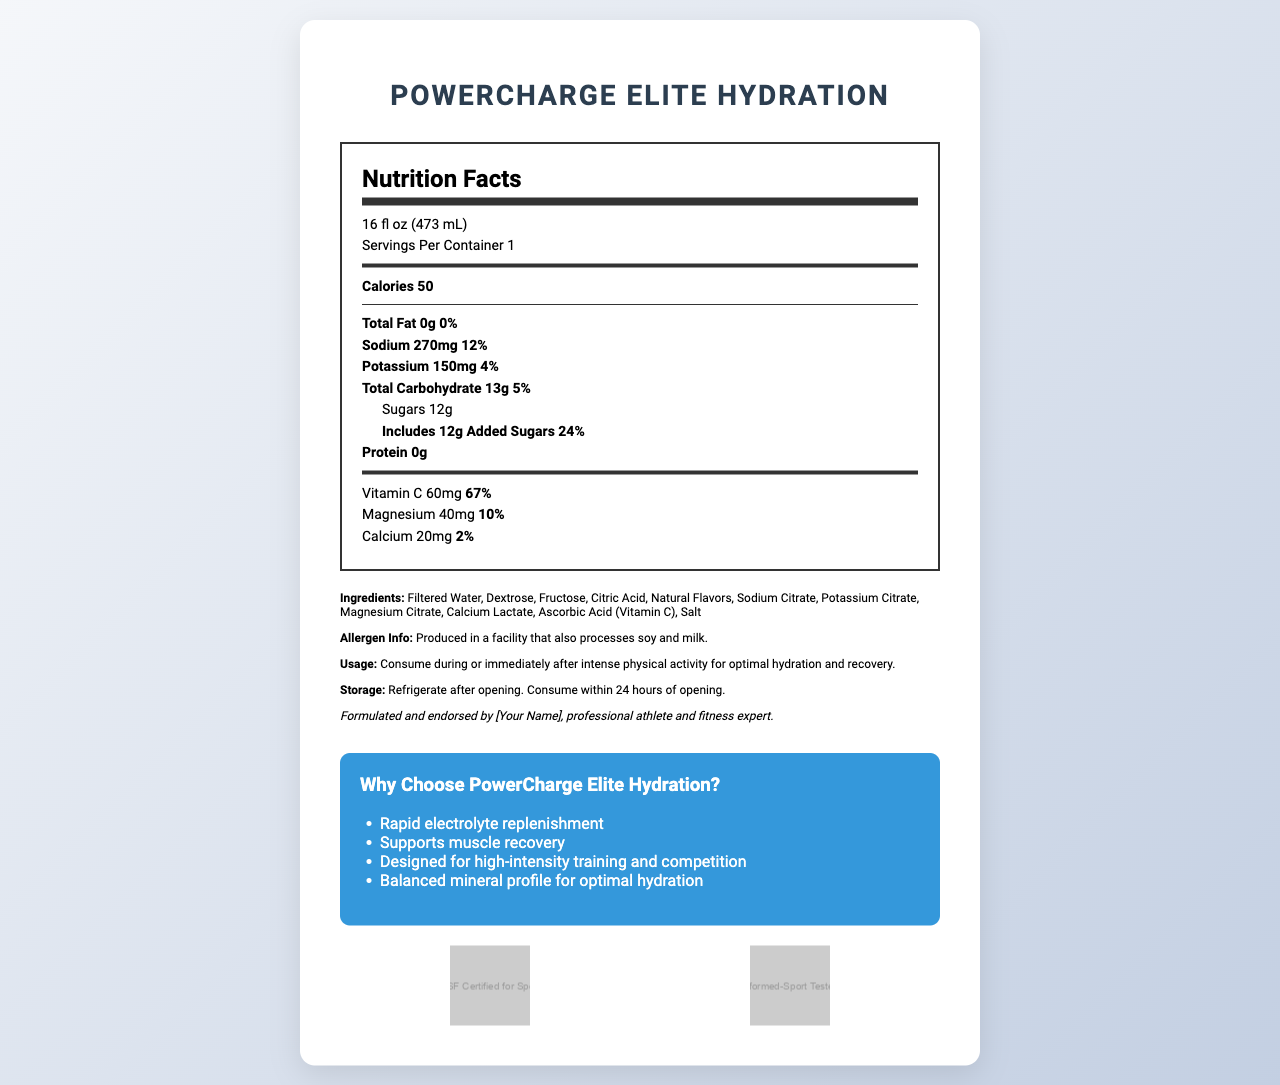where is the product's serving size listed? The serving size is located at the top of the nutrition label and is specified as 16 fl oz (473 mL).
Answer: 16 fl oz (473 mL) how many calories are in one serving? The number of calories per serving is listed at the top of the Nutrition Facts section and is 50 calories.
Answer: 50 what percentage of the daily value for sodium does one serving provide? The daily value percentage for sodium is listed next to the sodium amount and is specified as 12%.
Answer: 12% what is the amount of potassium in one serving? The amount of potassium is listed under sodium in the Nutrition Facts section with an amount of 150mg.
Answer: 150mg what percentage of the daily value for magnesium does one serving provide? The daily value percentage for magnesium is listed near the bottom of the Nutrition Facts and is specified as 10%.
Answer: 10% what are the first three ingredients listed? The first three ingredients listed in the Ingredients section are Filtered Water, Dextrose, and Fructose.
Answer: Filtered Water, Dextrose, Fructose what is the total carbohydrate content per serving? The total carbohydrate content per serving is listed under the Nutrition Facts and is specified as 13g.
Answer: 13g how much added sugar is in one serving? The amount of added sugar is listed under Total Carbohydrate in the Nutrition Facts section and is specified as 12g.
Answer: 12g what vitamins or minerals contribute to immunity support in this drink? A. Magnesium and Calcium B. Vitamin C and Magnesium C. Vitamin C and Potassium D. Sodium and Potassium Vitamin C and Potassium are listed in the Nutrition Facts section, and Vitamin C is known for its contributions to immune function.
Answer: C. Vitamin C and Potassium which certification ensures the product is tested for contaminants and banned substances? A. NSF Certified for Sport B. Informed-Sport Tested C. Both A and B The product has both NSF Certified for Sport and Informed-Sport Tested certifications, ensuring it is tested for contaminants and banned substances.
Answer: C. Both A and B should this product be refrigerated after opening? The usage instructions near the bottom of the document state that the product should be consumed within 24 hours of opening and refrigerated after opening.
Answer: Yes is this product suitable for high-intensity training and competition? One of the marketing claims listed in the document states that the product is designed for high-intensity training and competition.
Answer: Yes is this product free from allergens? The allergen information states that the product is produced in a facility that also processes soy and milk, indicating potential allergen presence.
Answer: No what is the main idea of this document? The document displays the nutrition label, ingredients, allergen information, usage and storage instructions, athlete endorsement, marketing claims, and product certifications, focusing on the electrolyte content and benefits for athletes.
Answer: The document provides detailed nutrition facts, ingredient information, usage instructions, and marketing claims for "PowerCharge Elite Hydration," an electrolyte-rich sports drink endorsed by a professional athlete, designed to support rapid hydration and recovery during high-intensity physical activities. what research backs up the effectiveness of this product for muscle recovery? The document does not provide any scientific research or studies that back up the effectiveness of the product for muscle recovery.
Answer: Cannot be determined 